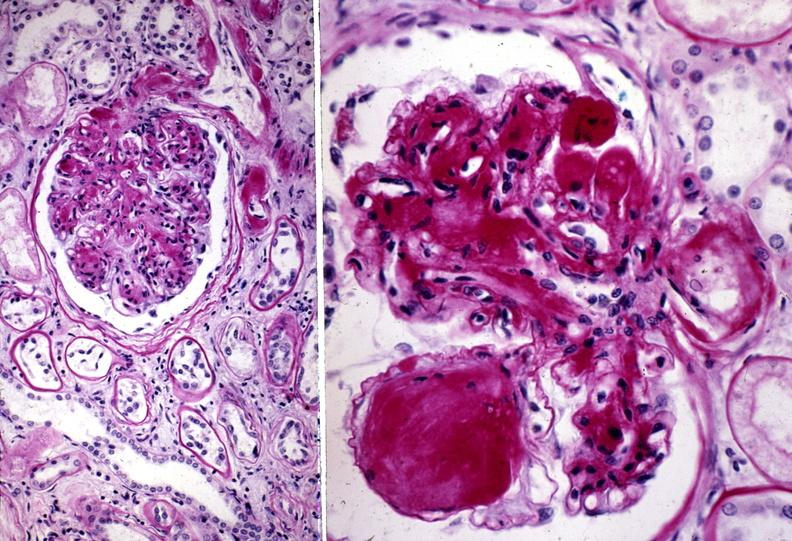where is this?
Answer the question using a single word or phrase. Urinary 